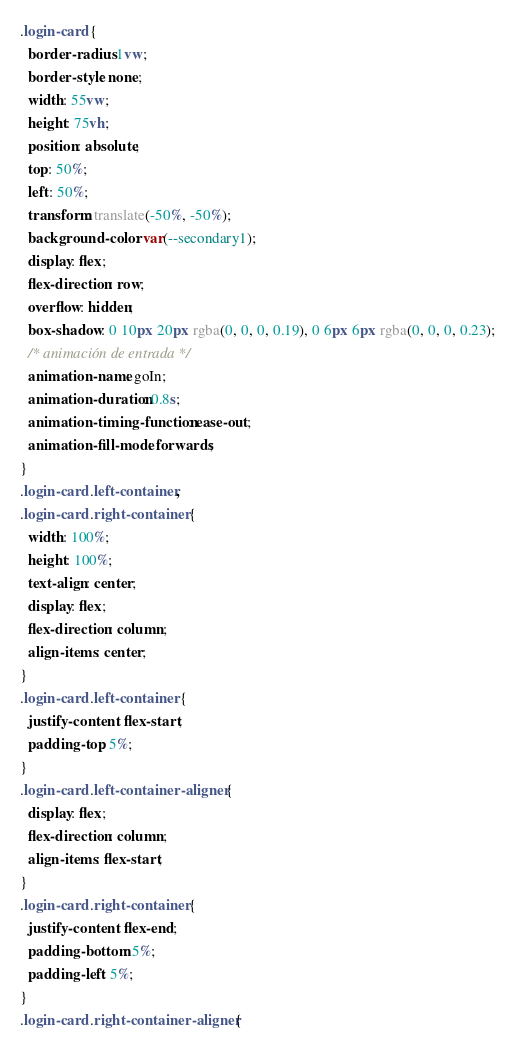Convert code to text. <code><loc_0><loc_0><loc_500><loc_500><_CSS_>.login-card {
  border-radius: 1vw;
  border-style: none;
  width: 55vw;
  height: 75vh;
  position: absolute;
  top: 50%;
  left: 50%;
  transform: translate(-50%, -50%);
  background-color: var(--secondary1);
  display: flex;
  flex-direction: row;
  overflow: hidden;
  box-shadow: 0 10px 20px rgba(0, 0, 0, 0.19), 0 6px 6px rgba(0, 0, 0, 0.23);
  /* animación de entrada */
  animation-name: goIn;
  animation-duration: 0.8s;
  animation-timing-function: ease-out;
  animation-fill-mode: forwards;
}
.login-card .left-container,
.login-card .right-container {
  width: 100%;
  height: 100%;
  text-align: center;
  display: flex;
  flex-direction: column;
  align-items: center;
}
.login-card .left-container {
  justify-content: flex-start;
  padding-top: 5%;
}
.login-card .left-container-aligner {
  display: flex;
  flex-direction: column;
  align-items: flex-start;
}
.login-card .right-container {
  justify-content: flex-end;
  padding-bottom: 5%;
  padding-left: 5%;
}
.login-card .right-container-aligner {</code> 